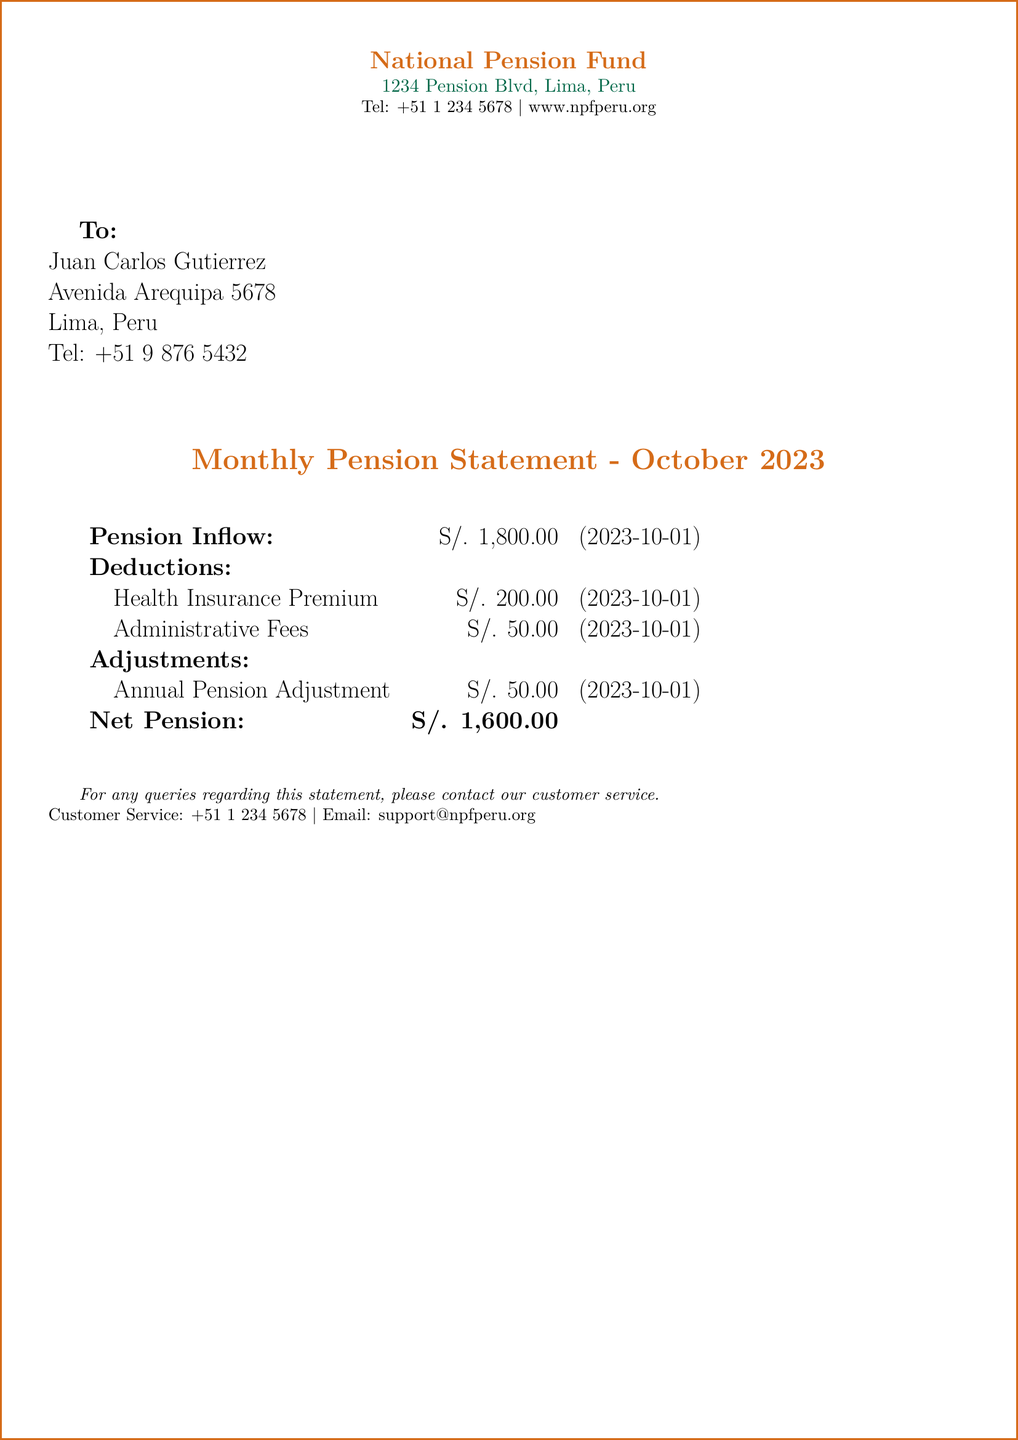What is the total pension inflow for October 2023? The pension inflow for October 2023 is stated directly in the document.
Answer: S/. 1,800.00 What is the amount deducted for health insurance? The document specifies the deduction for health insurance as part of the deductions section.
Answer: S/. 200.00 What is the net pension amount? The net pension amount is calculated by subtracting the total deductions from the inflow, which is stated in the document.
Answer: S/. 1,600.00 Which month is this pension statement for? The document title clearly states the month for which the statement is issued.
Answer: October 2023 What is the amount for administrative fees? The document lists the administrative fees under deductions, providing the specific amount.
Answer: S/. 50.00 What type of adjustment is mentioned in the statement? The document mentions an annual pension adjustment, which is part of the adjustments section.
Answer: Annual Pension Adjustment What is the total deduction amount? The total deduction amount can be found by summing both listed deductions in the document.
Answer: S/. 250.00 What is the address of the National Pension Fund? The address is provided at the top of the document, specifying the National Pension Fund's location.
Answer: 1234 Pension Blvd, Lima, Peru What is the contact number for customer service? The document provides a specific contact number for customer service at the bottom section.
Answer: +51 1 234 5678 